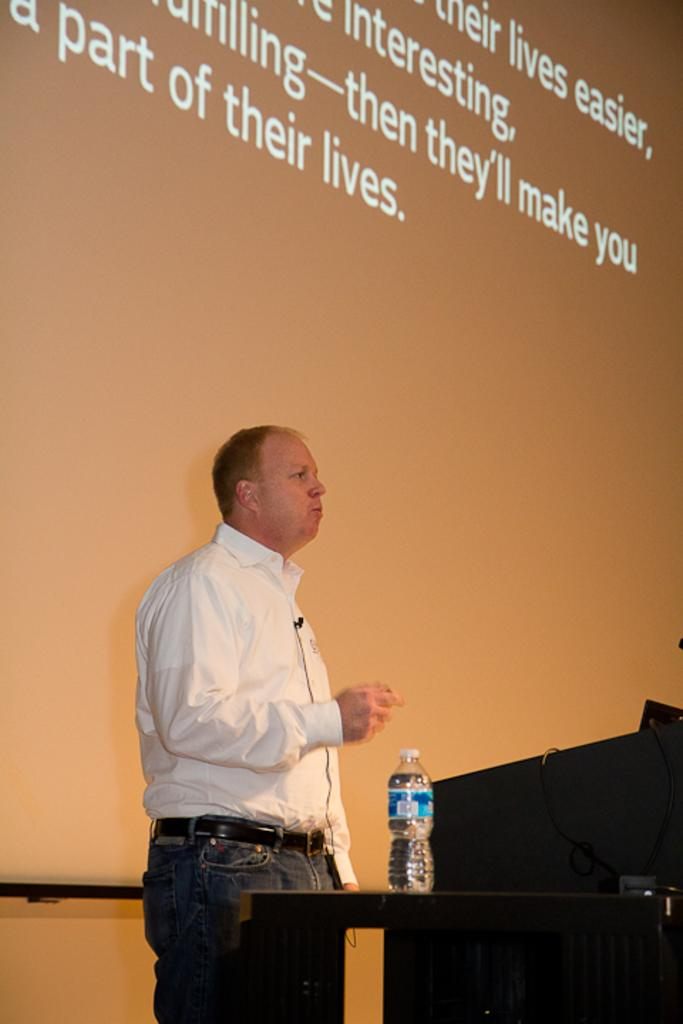What is the man near in the image? The man is standing near the podium in the image. What is located beside the podium? There is a table beside the podium. What is on the table? There is a bottle on the table. What can be seen in the background of the image? There is a screen in the background. Can you see the receipt for the bottle on the table in the image? There is no receipt visible in the image; only the bottle on the table is mentioned. 